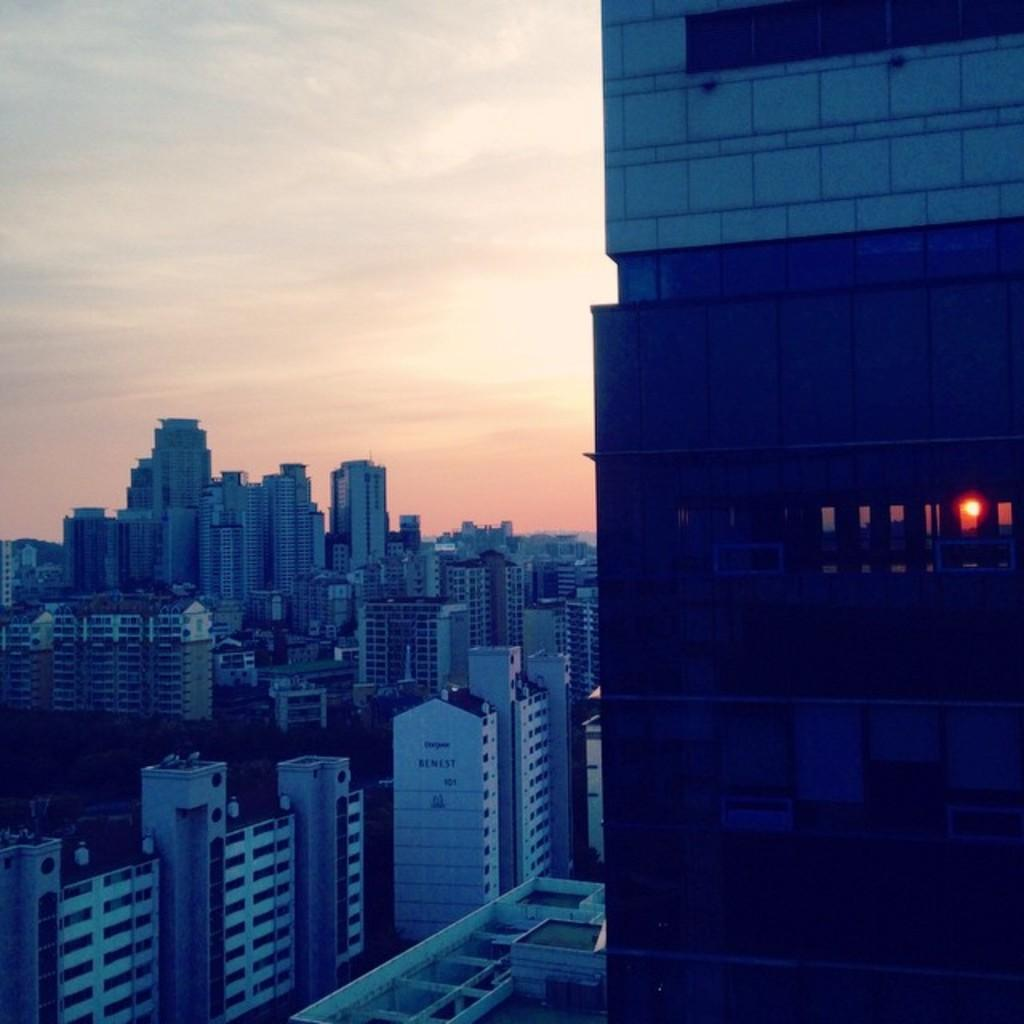What is the primary subject of the image? The primary subject of the image is many buildings. What can be seen in the background of the image? There is a sky visible in the background of the image. Can you describe a specific detail about one of the buildings? Yes, a light is visible through a building on the right side of the image. What type of apparatus can be seen driving through the buildings in the image? There is no apparatus or vehicle driving through the buildings in the image; it only shows the buildings and the sky. 